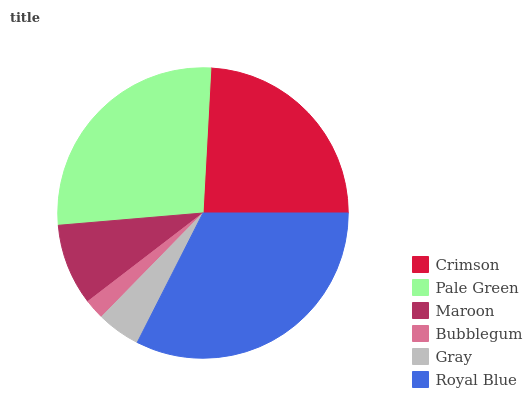Is Bubblegum the minimum?
Answer yes or no. Yes. Is Royal Blue the maximum?
Answer yes or no. Yes. Is Pale Green the minimum?
Answer yes or no. No. Is Pale Green the maximum?
Answer yes or no. No. Is Pale Green greater than Crimson?
Answer yes or no. Yes. Is Crimson less than Pale Green?
Answer yes or no. Yes. Is Crimson greater than Pale Green?
Answer yes or no. No. Is Pale Green less than Crimson?
Answer yes or no. No. Is Crimson the high median?
Answer yes or no. Yes. Is Maroon the low median?
Answer yes or no. Yes. Is Gray the high median?
Answer yes or no. No. Is Pale Green the low median?
Answer yes or no. No. 